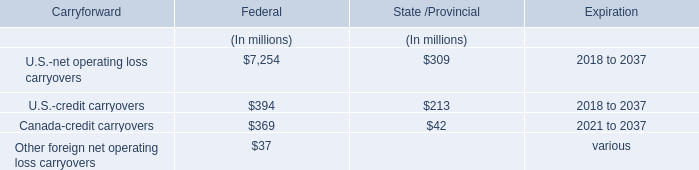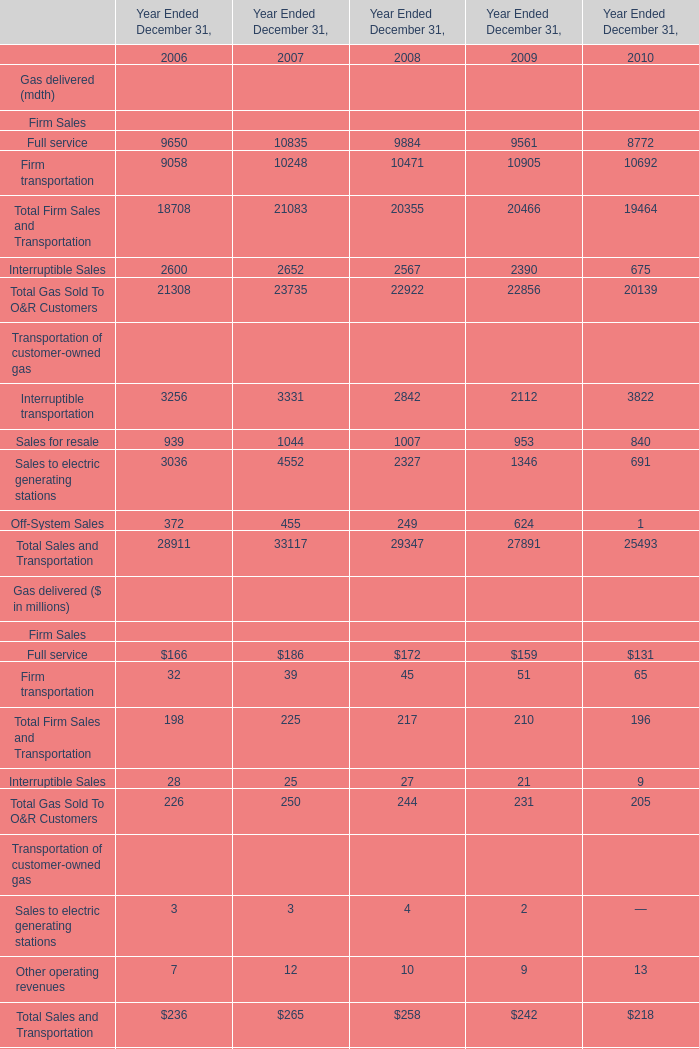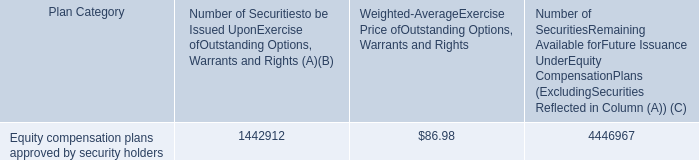Does Full service for Gas delivered ($ in millions) keeps increasing each year between 2007 and 2008? 
Answer: No. 